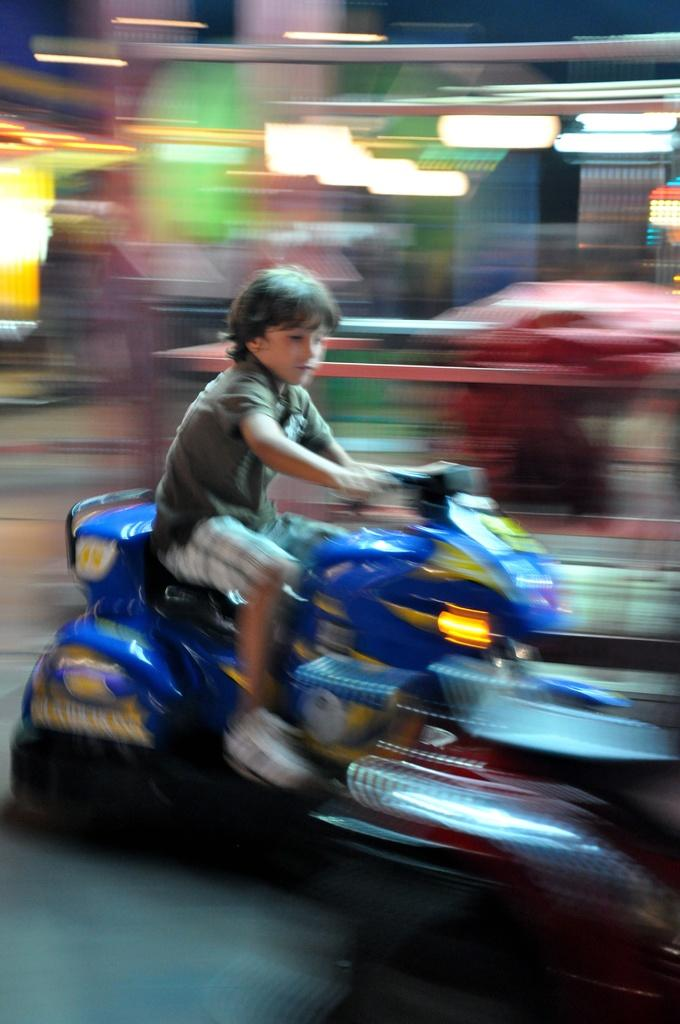What is the main subject of the image? The main subject of the image is a kid. What is the kid doing in the image? The kid is riding a toy bike in the image. What color is the toy bike? The toy bike is blue in color. What type of feast is being prepared by the kid in the image? There is no indication of a feast or any food preparation in the image; the kid is simply riding a blue toy bike. 